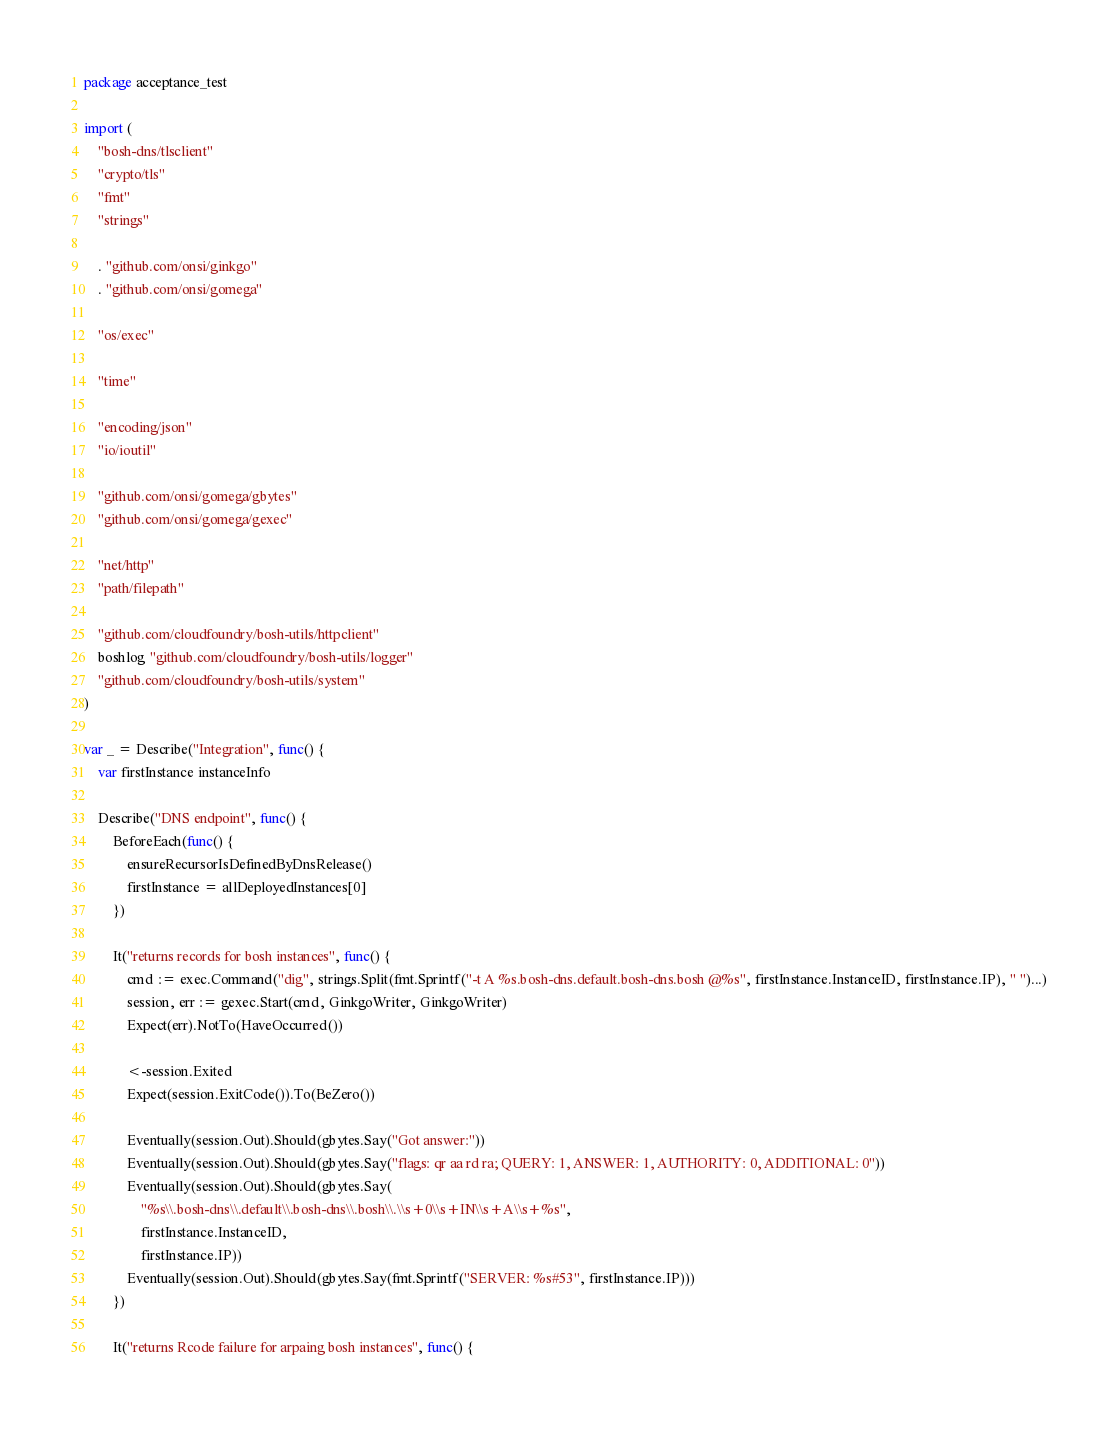Convert code to text. <code><loc_0><loc_0><loc_500><loc_500><_Go_>package acceptance_test

import (
	"bosh-dns/tlsclient"
	"crypto/tls"
	"fmt"
	"strings"

	. "github.com/onsi/ginkgo"
	. "github.com/onsi/gomega"

	"os/exec"

	"time"

	"encoding/json"
	"io/ioutil"

	"github.com/onsi/gomega/gbytes"
	"github.com/onsi/gomega/gexec"

	"net/http"
	"path/filepath"

	"github.com/cloudfoundry/bosh-utils/httpclient"
	boshlog "github.com/cloudfoundry/bosh-utils/logger"
	"github.com/cloudfoundry/bosh-utils/system"
)

var _ = Describe("Integration", func() {
	var firstInstance instanceInfo

	Describe("DNS endpoint", func() {
		BeforeEach(func() {
			ensureRecursorIsDefinedByDnsRelease()
			firstInstance = allDeployedInstances[0]
		})

		It("returns records for bosh instances", func() {
			cmd := exec.Command("dig", strings.Split(fmt.Sprintf("-t A %s.bosh-dns.default.bosh-dns.bosh @%s", firstInstance.InstanceID, firstInstance.IP), " ")...)
			session, err := gexec.Start(cmd, GinkgoWriter, GinkgoWriter)
			Expect(err).NotTo(HaveOccurred())

			<-session.Exited
			Expect(session.ExitCode()).To(BeZero())

			Eventually(session.Out).Should(gbytes.Say("Got answer:"))
			Eventually(session.Out).Should(gbytes.Say("flags: qr aa rd ra; QUERY: 1, ANSWER: 1, AUTHORITY: 0, ADDITIONAL: 0"))
			Eventually(session.Out).Should(gbytes.Say(
				"%s\\.bosh-dns\\.default\\.bosh-dns\\.bosh\\.\\s+0\\s+IN\\s+A\\s+%s",
				firstInstance.InstanceID,
				firstInstance.IP))
			Eventually(session.Out).Should(gbytes.Say(fmt.Sprintf("SERVER: %s#53", firstInstance.IP)))
		})

		It("returns Rcode failure for arpaing bosh instances", func() {</code> 